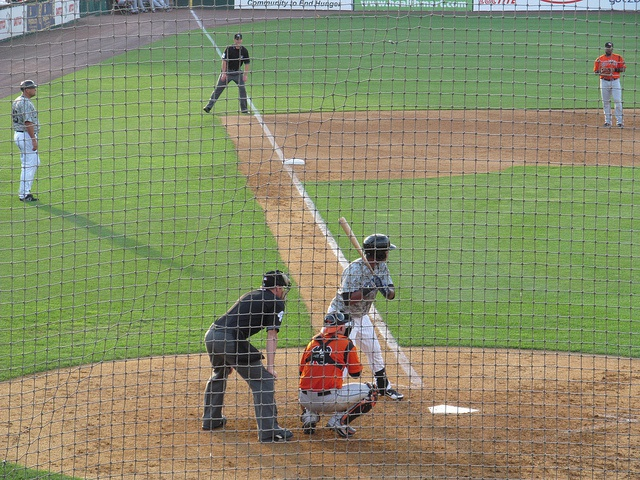Describe the objects in this image and their specific colors. I can see people in lightblue, black, and gray tones, people in lightblue, gray, brown, black, and darkgray tones, people in lightblue, gray, darkgray, black, and lavender tones, people in lightblue, gray, and darkgray tones, and people in lightblue, darkgray, gray, and brown tones in this image. 